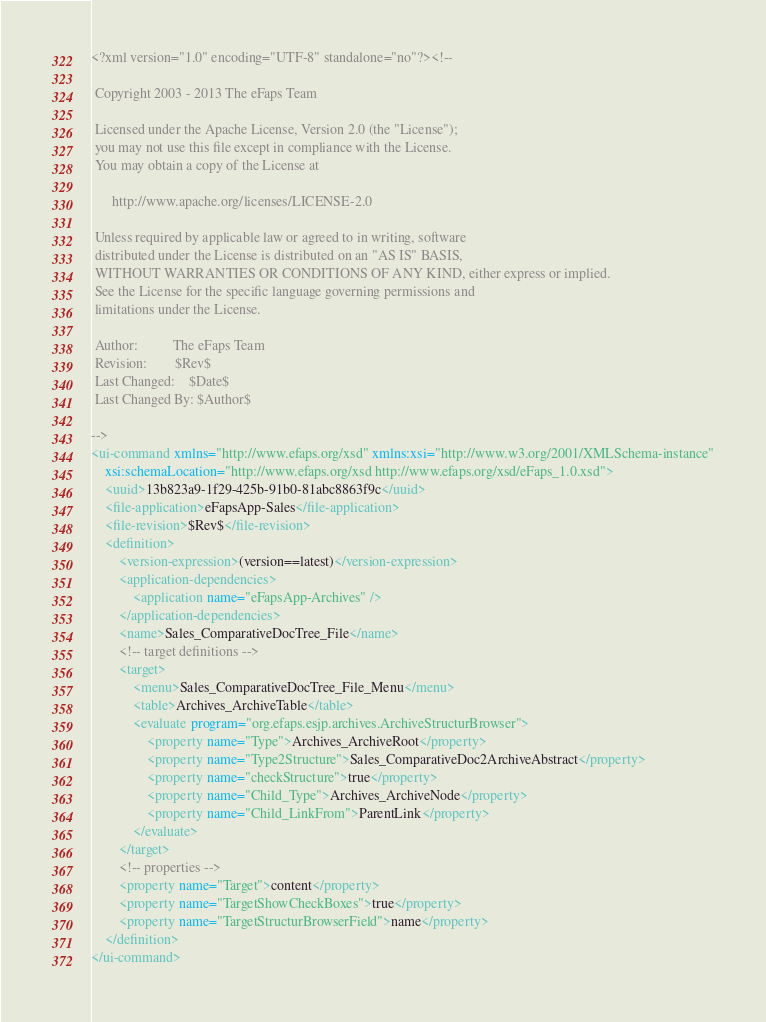Convert code to text. <code><loc_0><loc_0><loc_500><loc_500><_XML_><?xml version="1.0" encoding="UTF-8" standalone="no"?><!--

 Copyright 2003 - 2013 The eFaps Team

 Licensed under the Apache License, Version 2.0 (the "License");
 you may not use this file except in compliance with the License.
 You may obtain a copy of the License at

      http://www.apache.org/licenses/LICENSE-2.0

 Unless required by applicable law or agreed to in writing, software
 distributed under the License is distributed on an "AS IS" BASIS,
 WITHOUT WARRANTIES OR CONDITIONS OF ANY KIND, either express or implied.
 See the License for the specific language governing permissions and
 limitations under the License.

 Author:          The eFaps Team
 Revision:        $Rev$
 Last Changed:    $Date$
 Last Changed By: $Author$

-->
<ui-command xmlns="http://www.efaps.org/xsd" xmlns:xsi="http://www.w3.org/2001/XMLSchema-instance"
    xsi:schemaLocation="http://www.efaps.org/xsd http://www.efaps.org/xsd/eFaps_1.0.xsd">
    <uuid>13b823a9-1f29-425b-91b0-81abc8863f9c</uuid>
    <file-application>eFapsApp-Sales</file-application>
    <file-revision>$Rev$</file-revision>
    <definition>
        <version-expression>(version==latest)</version-expression>
        <application-dependencies>
            <application name="eFapsApp-Archives" />
        </application-dependencies>
        <name>Sales_ComparativeDocTree_File</name>
        <!-- target definitions -->
        <target>
            <menu>Sales_ComparativeDocTree_File_Menu</menu>
            <table>Archives_ArchiveTable</table>
            <evaluate program="org.efaps.esjp.archives.ArchiveStructurBrowser">
                <property name="Type">Archives_ArchiveRoot</property>
                <property name="Type2Structure">Sales_ComparativeDoc2ArchiveAbstract</property>
                <property name="checkStructure">true</property>
                <property name="Child_Type">Archives_ArchiveNode</property>
                <property name="Child_LinkFrom">ParentLink</property>
            </evaluate>
        </target>
        <!-- properties -->
        <property name="Target">content</property>
        <property name="TargetShowCheckBoxes">true</property>
        <property name="TargetStructurBrowserField">name</property>
    </definition>
</ui-command>
</code> 